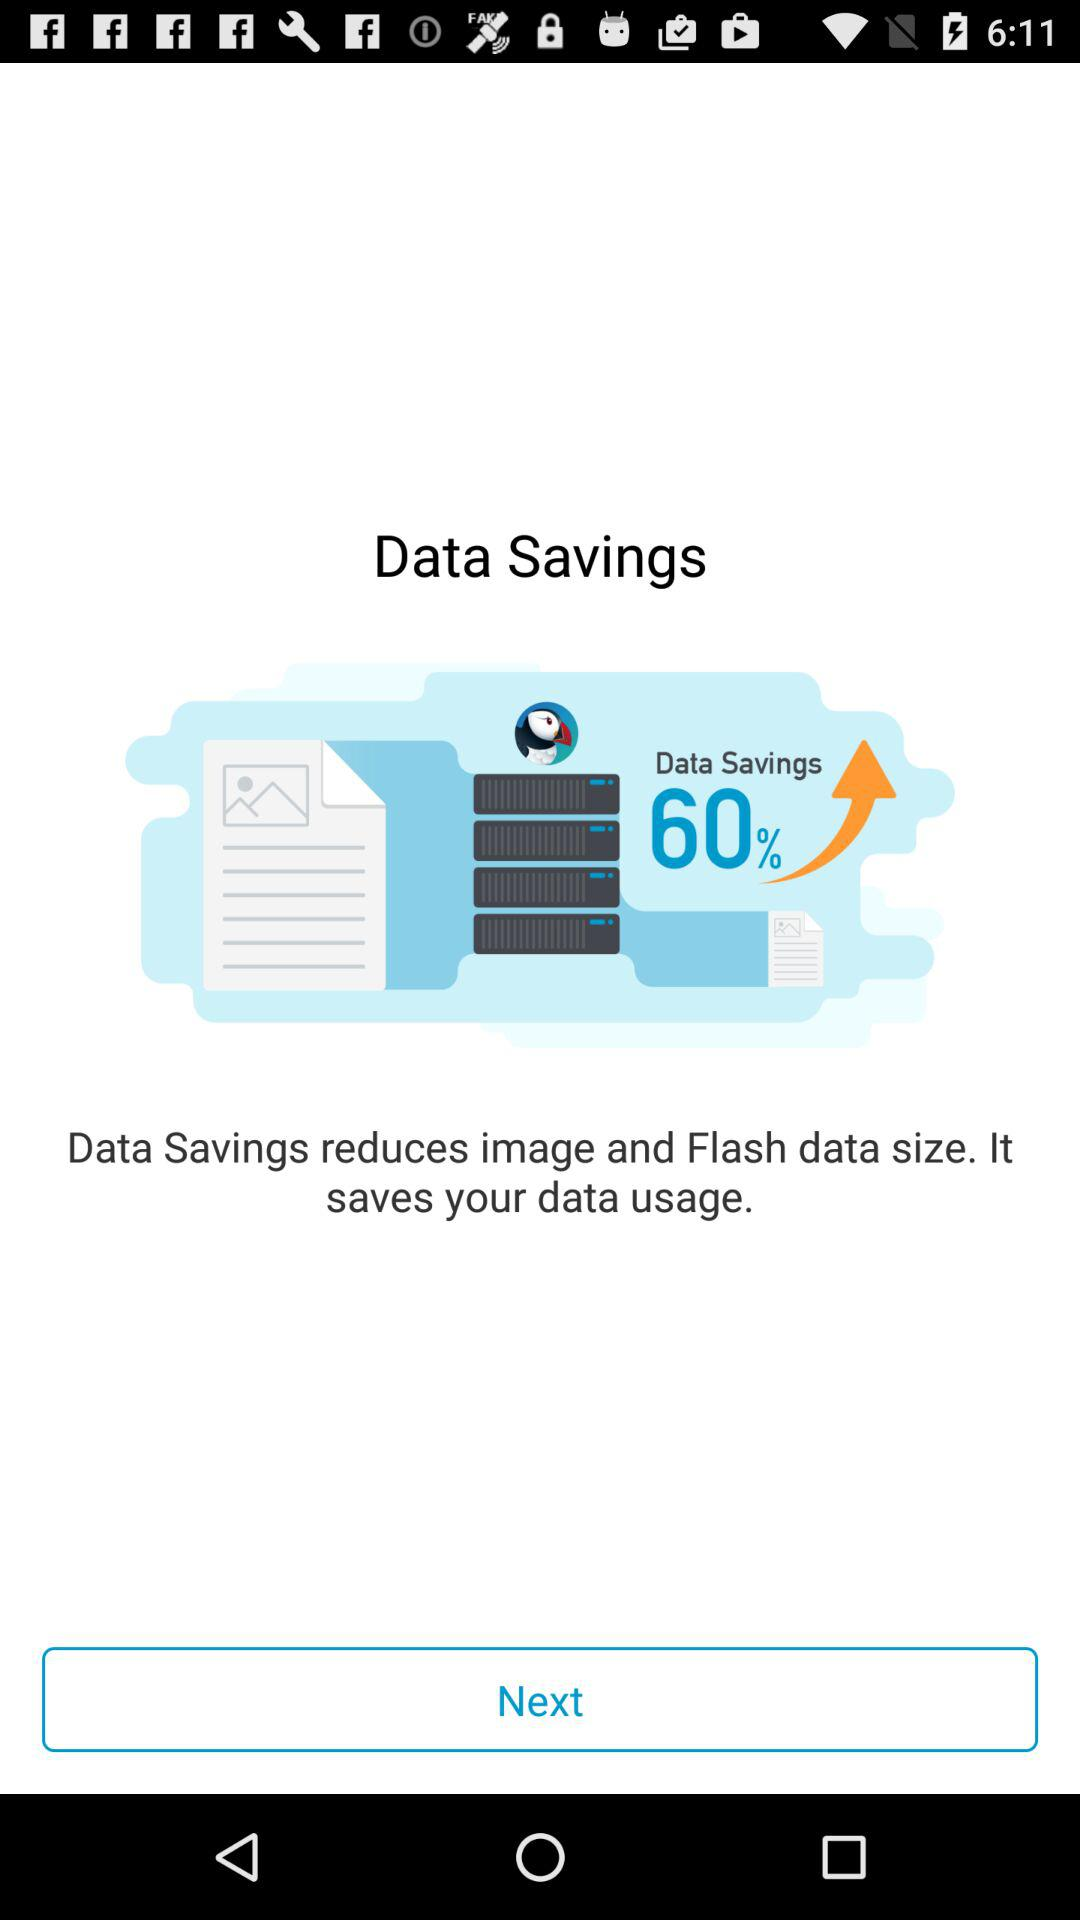What data size is reduced by "Data Savings" to save the data usage? "Data Savings" reduces image and Flash data size. 